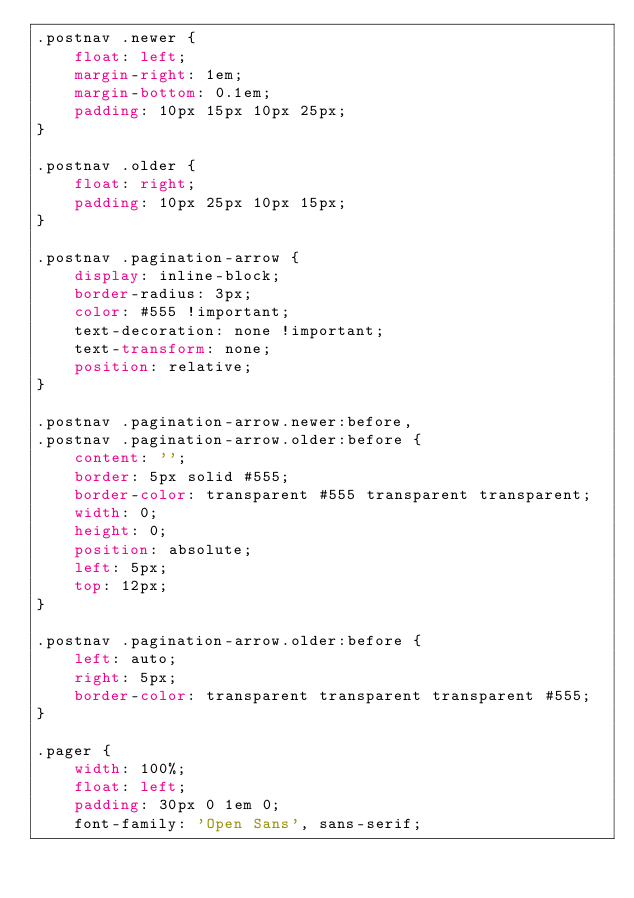<code> <loc_0><loc_0><loc_500><loc_500><_CSS_>.postnav .newer {
    float: left;
    margin-right: 1em;
    margin-bottom: 0.1em;
    padding: 10px 15px 10px 25px;
}

.postnav .older {
    float: right;
    padding: 10px 25px 10px 15px;
}

.postnav .pagination-arrow {
    display: inline-block;
    border-radius: 3px;
    color: #555 !important;
    text-decoration: none !important;
    text-transform: none;
    position: relative;
}

.postnav .pagination-arrow.newer:before,
.postnav .pagination-arrow.older:before {
    content: '';
    border: 5px solid #555;
    border-color: transparent #555 transparent transparent;
    width: 0;
    height: 0;
    position: absolute;
    left: 5px;
    top: 12px;
}

.postnav .pagination-arrow.older:before {
    left: auto;
    right: 5px;
    border-color: transparent transparent transparent #555;
}

.pager {
    width: 100%;
    float: left;
    padding: 30px 0 1em 0;
    font-family: 'Open Sans', sans-serif;</code> 